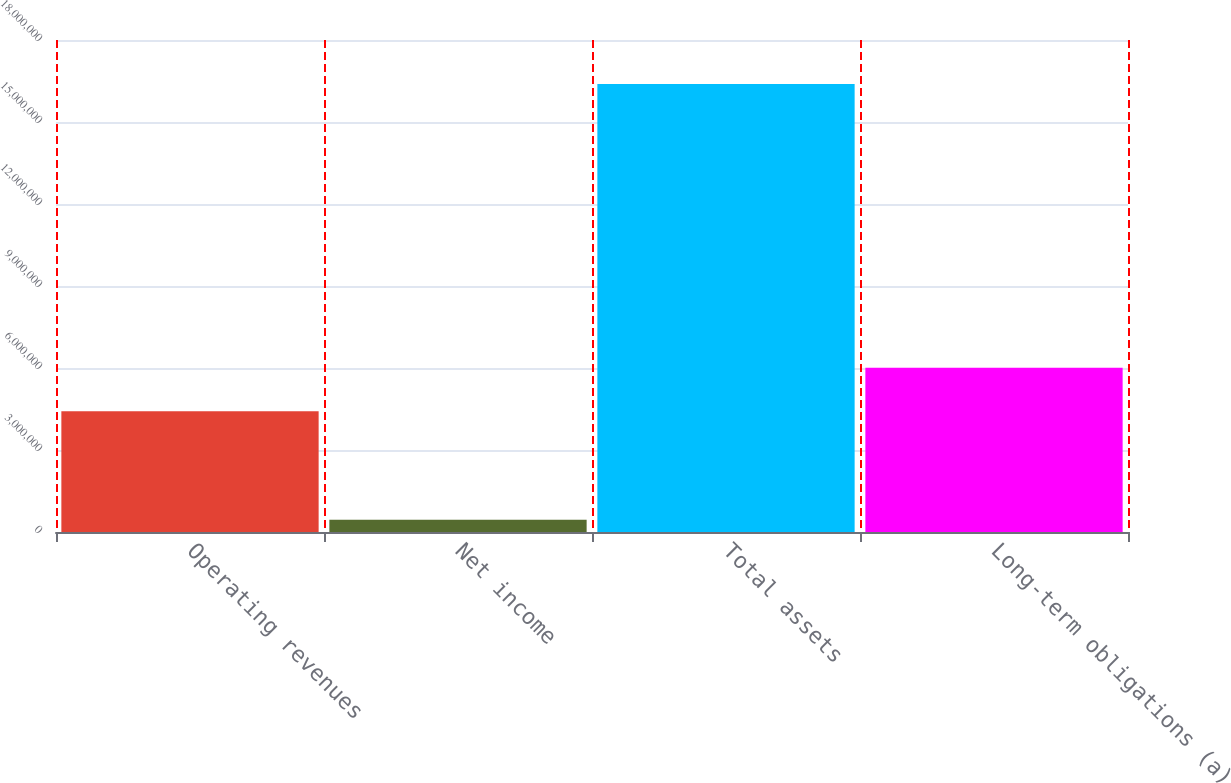<chart> <loc_0><loc_0><loc_500><loc_500><bar_chart><fcel>Operating revenues<fcel>Net income<fcel>Total assets<fcel>Long-term obligations (a)<nl><fcel>4.41715e+06<fcel>446639<fcel>1.63874e+07<fcel>6.01123e+06<nl></chart> 